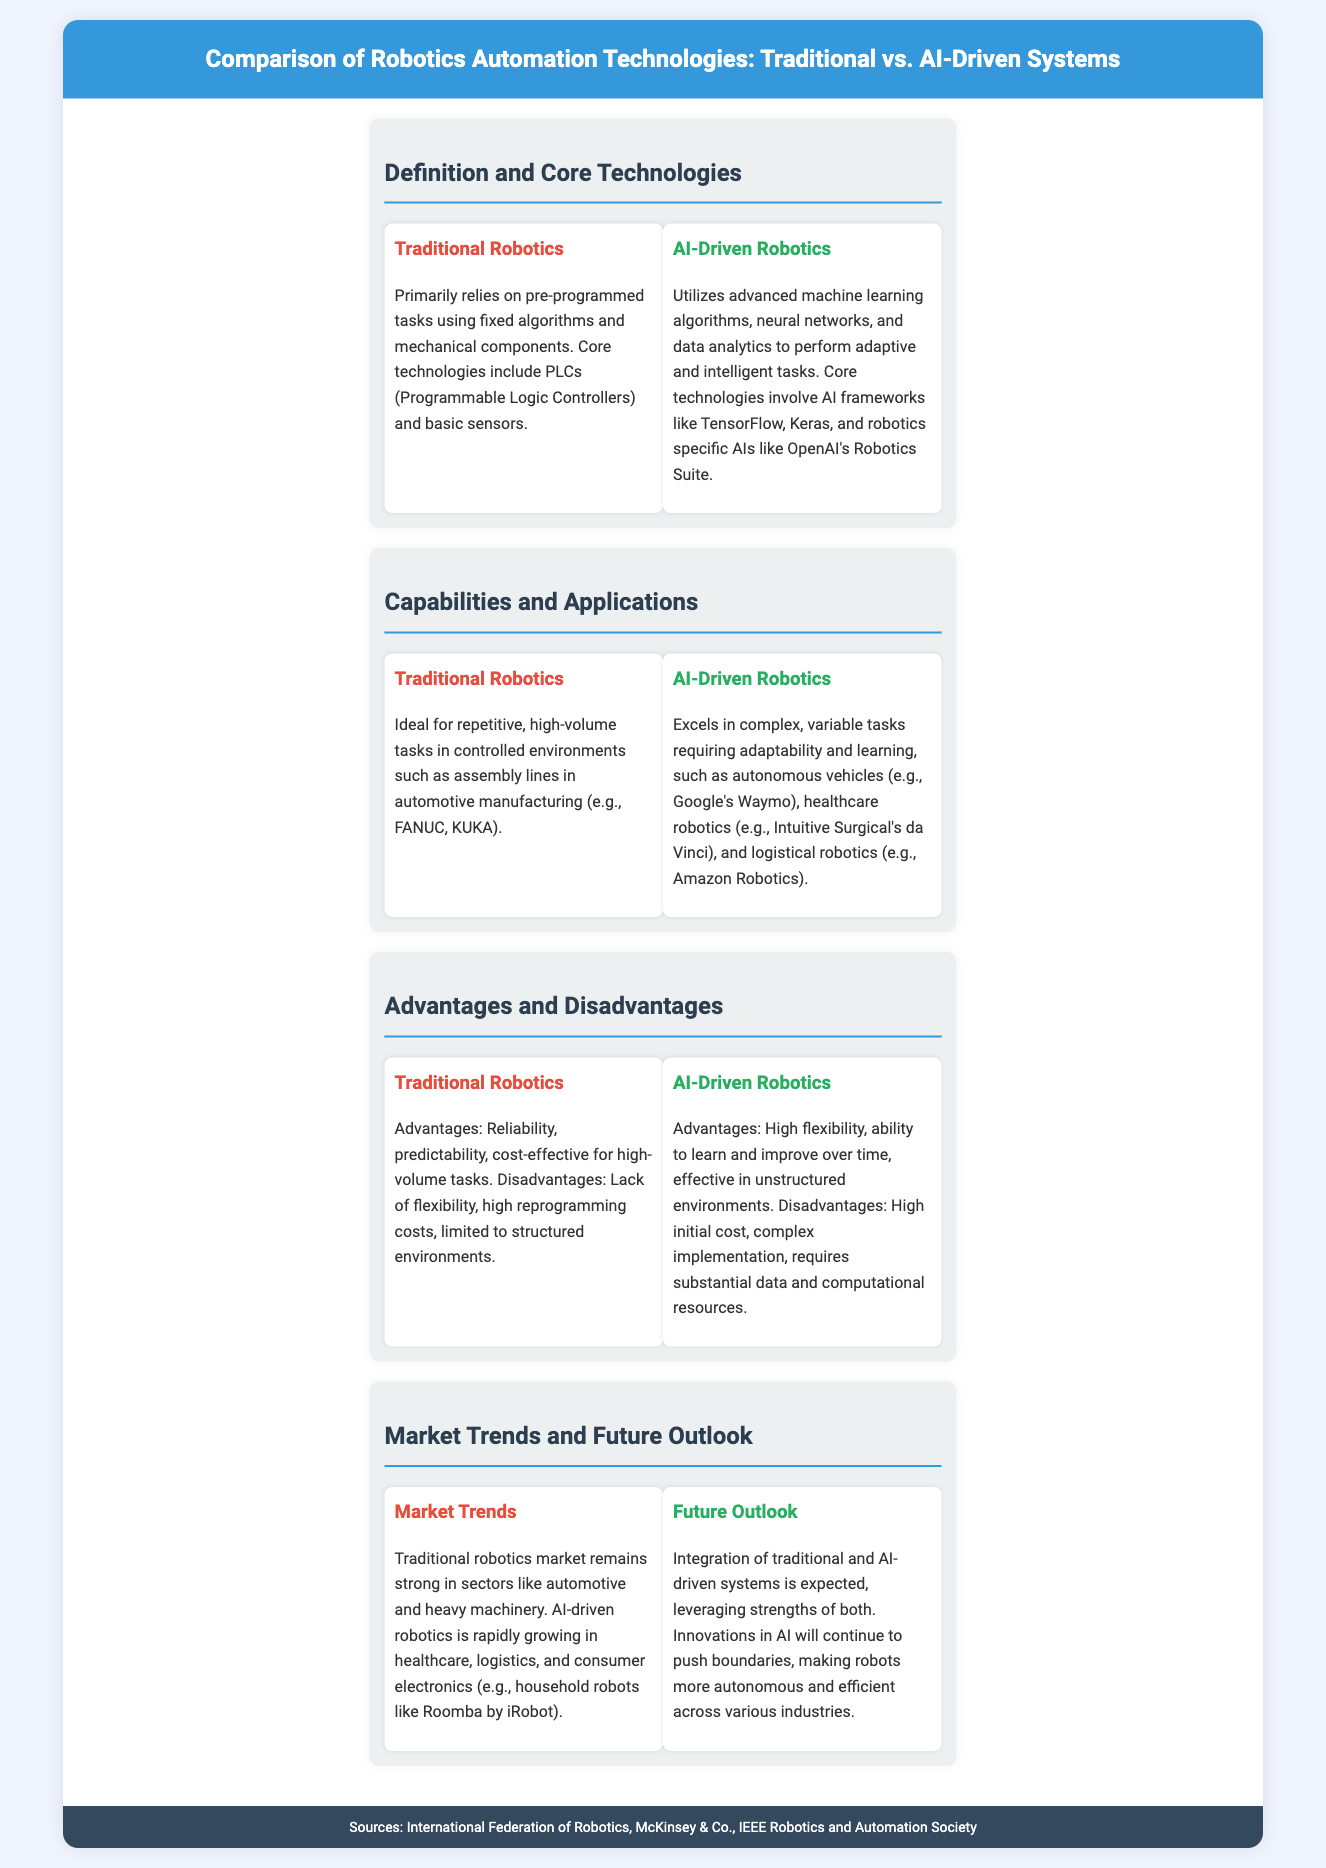What technologies are core to traditional robotics? The core technologies include PLCs (Programmable Logic Controllers) and basic sensors.
Answer: PLCs and basic sensors What are the primary advantages of AI-driven robotics? The advantages include high flexibility, ability to learn and improve over time, and effectiveness in unstructured environments.
Answer: High flexibility, learning ability, effectiveness Which sectors are traditional robotics markets strong in? Traditional robotics market remains strong in sectors like automotive and heavy machinery.
Answer: Automotive and heavy machinery What type of tasks do AI-driven robotics excel in? AI-driven robotics excels in complex, variable tasks requiring adaptability and learning.
Answer: Complex, variable tasks What is a common application of traditional robotics? A common application is in assembly lines in automotive manufacturing.
Answer: Assembly lines in automotive manufacturing What kind of data analytics does AI-driven robotics utilize? AI-driven robotics utilizes advanced machine learning algorithms, neural networks, and data analytics.
Answer: Advanced machine learning algorithms What is a disadvantage of traditional robotics? A disadvantage is the lack of flexibility.
Answer: Lack of flexibility What is the future outlook for robotics systems? The future outlook indicates integration of traditional and AI-driven systems.
Answer: Integration of traditional and AI-driven systems 